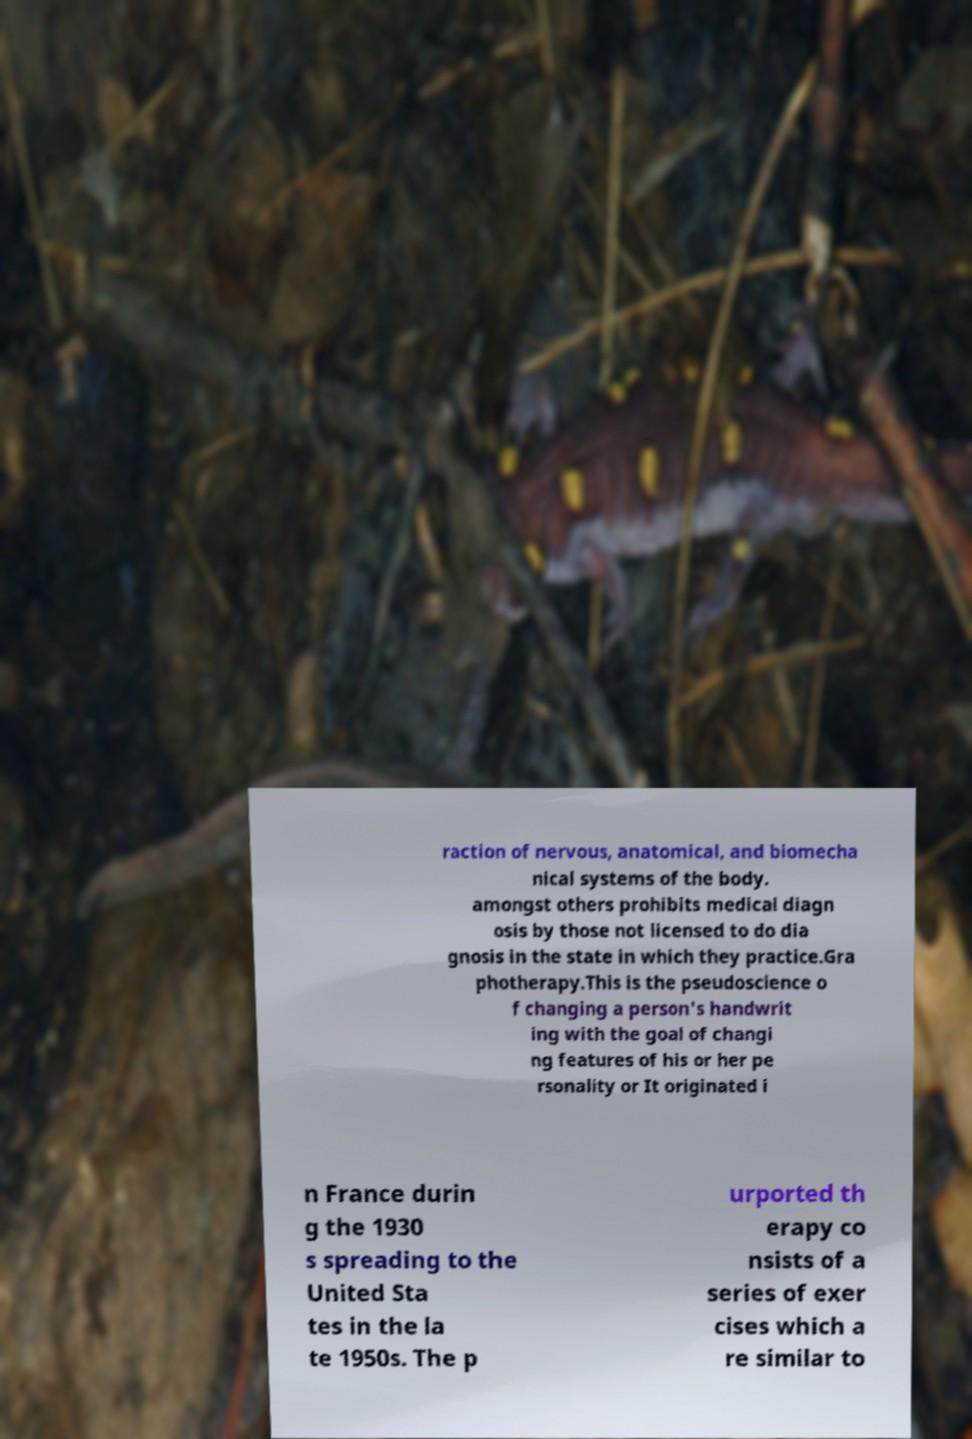Can you accurately transcribe the text from the provided image for me? raction of nervous, anatomical, and biomecha nical systems of the body. amongst others prohibits medical diagn osis by those not licensed to do dia gnosis in the state in which they practice.Gra photherapy.This is the pseudoscience o f changing a person's handwrit ing with the goal of changi ng features of his or her pe rsonality or It originated i n France durin g the 1930 s spreading to the United Sta tes in the la te 1950s. The p urported th erapy co nsists of a series of exer cises which a re similar to 